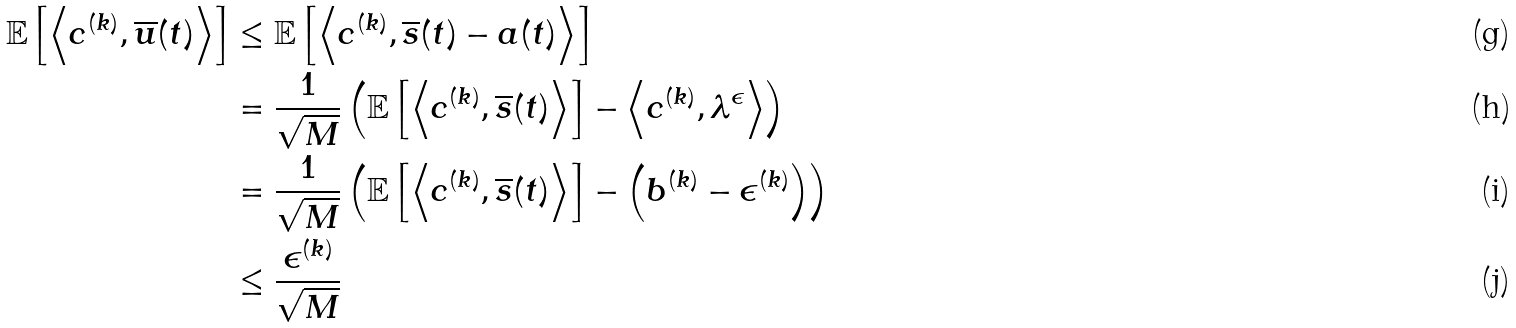Convert formula to latex. <formula><loc_0><loc_0><loc_500><loc_500>\mathbb { E } \left [ \left \langle c ^ { ( k ) } , \overline { u } ( t ) \right \rangle \right ] & \leq \mathbb { E } \left [ \left \langle c ^ { ( k ) } , \overline { s } ( t ) - a ( t ) \right \rangle \right ] \\ & = \frac { 1 } { \sqrt { M } } \left ( \mathbb { E } \left [ \left \langle c ^ { ( k ) } , \overline { s } ( t ) \right \rangle \right ] - \left \langle c ^ { ( k ) } , \lambda ^ { \epsilon } \right \rangle \right ) \\ & = \frac { 1 } { \sqrt { M } } \left ( \mathbb { E } \left [ \left \langle c ^ { ( k ) } , \overline { s } ( t ) \right \rangle \right ] - \left ( b ^ { ( k ) } - \epsilon ^ { ( k ) } \right ) \right ) \\ & \leq \frac { \epsilon ^ { ( k ) } } { \sqrt { M } }</formula> 